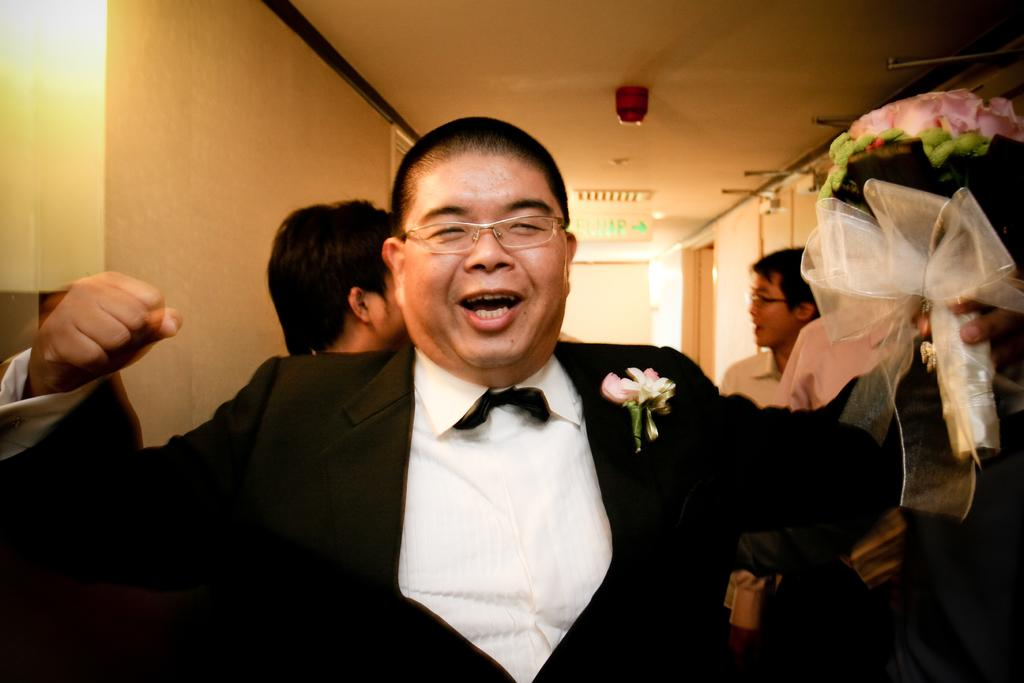What is the person in the image wearing? The person in the image is wearing a suit. What is the person holding in the image? The person is holding a flower bouquet. What is the facial expression of the person in the image? The person is smiling. What can be seen in the background of the image? There are people, a wall, a sign board, a ceiling, and other objects visible in the background of the image. What type of crown is the minister wearing in the image? There is no minister or crown present in the image. Can you describe the insect that is crawling on the person's shoulder in the image? There is no insect visible on the person's shoulder in the image. 